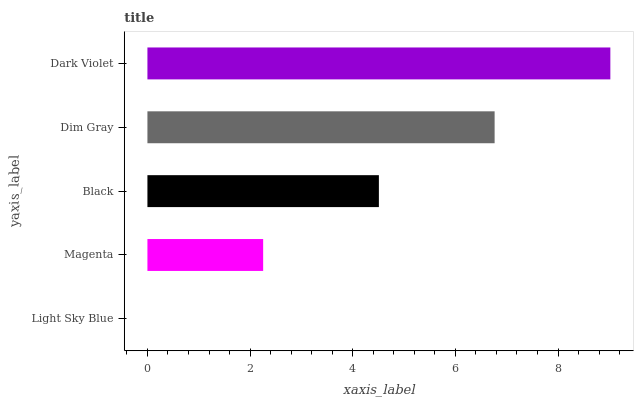Is Light Sky Blue the minimum?
Answer yes or no. Yes. Is Dark Violet the maximum?
Answer yes or no. Yes. Is Magenta the minimum?
Answer yes or no. No. Is Magenta the maximum?
Answer yes or no. No. Is Magenta greater than Light Sky Blue?
Answer yes or no. Yes. Is Light Sky Blue less than Magenta?
Answer yes or no. Yes. Is Light Sky Blue greater than Magenta?
Answer yes or no. No. Is Magenta less than Light Sky Blue?
Answer yes or no. No. Is Black the high median?
Answer yes or no. Yes. Is Black the low median?
Answer yes or no. Yes. Is Dark Violet the high median?
Answer yes or no. No. Is Magenta the low median?
Answer yes or no. No. 